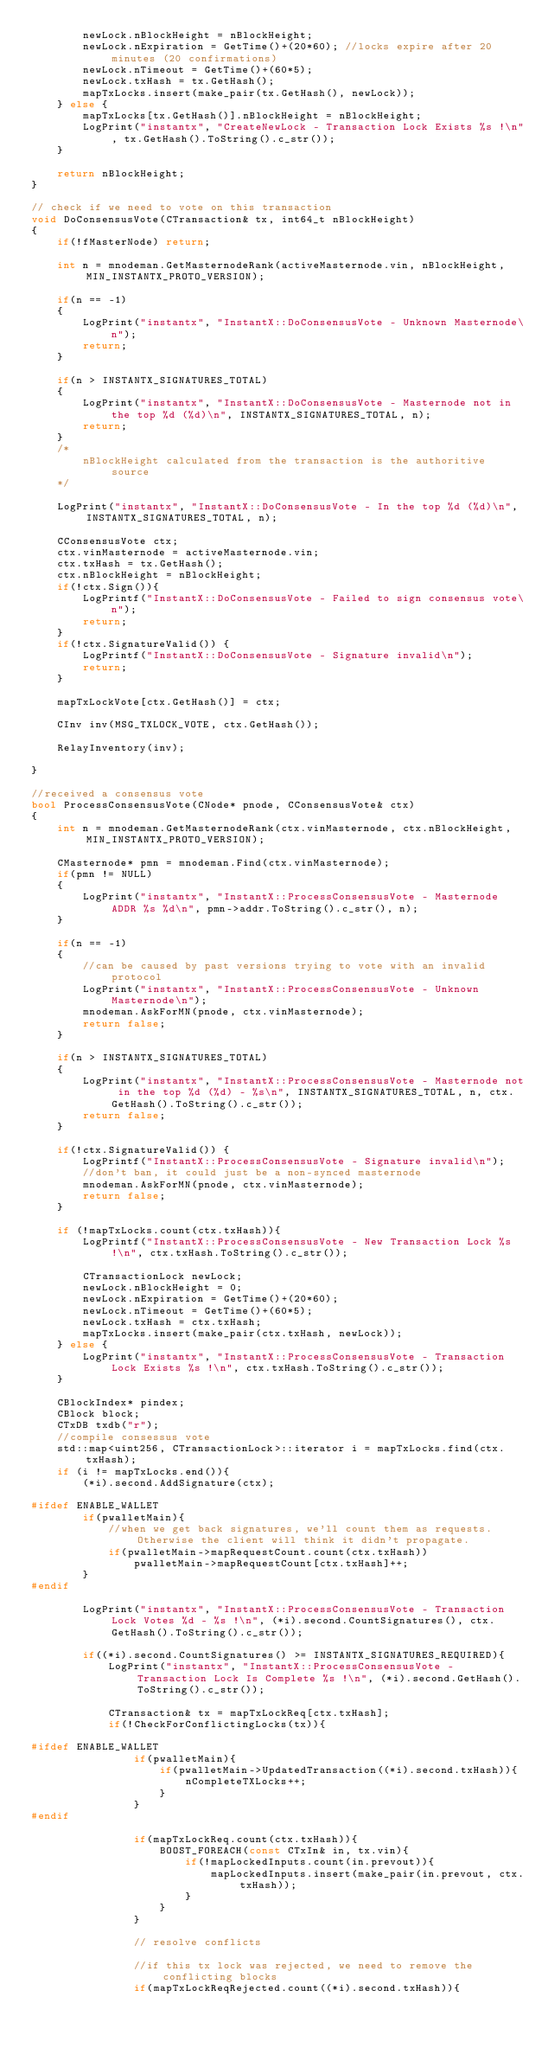<code> <loc_0><loc_0><loc_500><loc_500><_C++_>        newLock.nBlockHeight = nBlockHeight;
        newLock.nExpiration = GetTime()+(20*60); //locks expire after 20 minutes (20 confirmations)
        newLock.nTimeout = GetTime()+(60*5);
        newLock.txHash = tx.GetHash();
        mapTxLocks.insert(make_pair(tx.GetHash(), newLock));
    } else {
        mapTxLocks[tx.GetHash()].nBlockHeight = nBlockHeight;
        LogPrint("instantx", "CreateNewLock - Transaction Lock Exists %s !\n", tx.GetHash().ToString().c_str());
    }

    return nBlockHeight;
}

// check if we need to vote on this transaction
void DoConsensusVote(CTransaction& tx, int64_t nBlockHeight)
{
    if(!fMasterNode) return;

    int n = mnodeman.GetMasternodeRank(activeMasternode.vin, nBlockHeight, MIN_INSTANTX_PROTO_VERSION);

    if(n == -1)
    {
        LogPrint("instantx", "InstantX::DoConsensusVote - Unknown Masternode\n");
        return;
    }

    if(n > INSTANTX_SIGNATURES_TOTAL)
    {
        LogPrint("instantx", "InstantX::DoConsensusVote - Masternode not in the top %d (%d)\n", INSTANTX_SIGNATURES_TOTAL, n);
        return;
    }
    /*
        nBlockHeight calculated from the transaction is the authoritive source
    */

    LogPrint("instantx", "InstantX::DoConsensusVote - In the top %d (%d)\n", INSTANTX_SIGNATURES_TOTAL, n);

    CConsensusVote ctx;
    ctx.vinMasternode = activeMasternode.vin;
    ctx.txHash = tx.GetHash();
    ctx.nBlockHeight = nBlockHeight;
    if(!ctx.Sign()){
        LogPrintf("InstantX::DoConsensusVote - Failed to sign consensus vote\n");
        return;
    }
    if(!ctx.SignatureValid()) {
        LogPrintf("InstantX::DoConsensusVote - Signature invalid\n");
        return;
    }

    mapTxLockVote[ctx.GetHash()] = ctx;

    CInv inv(MSG_TXLOCK_VOTE, ctx.GetHash());

    RelayInventory(inv);

}

//received a consensus vote
bool ProcessConsensusVote(CNode* pnode, CConsensusVote& ctx)
{
    int n = mnodeman.GetMasternodeRank(ctx.vinMasternode, ctx.nBlockHeight, MIN_INSTANTX_PROTO_VERSION);

    CMasternode* pmn = mnodeman.Find(ctx.vinMasternode);
    if(pmn != NULL)
    {
        LogPrint("instantx", "InstantX::ProcessConsensusVote - Masternode ADDR %s %d\n", pmn->addr.ToString().c_str(), n);
    }

    if(n == -1)
    {
        //can be caused by past versions trying to vote with an invalid protocol
        LogPrint("instantx", "InstantX::ProcessConsensusVote - Unknown Masternode\n");
        mnodeman.AskForMN(pnode, ctx.vinMasternode);
        return false;
    }

    if(n > INSTANTX_SIGNATURES_TOTAL)
    {
        LogPrint("instantx", "InstantX::ProcessConsensusVote - Masternode not in the top %d (%d) - %s\n", INSTANTX_SIGNATURES_TOTAL, n, ctx.GetHash().ToString().c_str());
        return false;
    }

    if(!ctx.SignatureValid()) {
        LogPrintf("InstantX::ProcessConsensusVote - Signature invalid\n");
        //don't ban, it could just be a non-synced masternode
        mnodeman.AskForMN(pnode, ctx.vinMasternode);
        return false;
    }

    if (!mapTxLocks.count(ctx.txHash)){
        LogPrintf("InstantX::ProcessConsensusVote - New Transaction Lock %s !\n", ctx.txHash.ToString().c_str());

        CTransactionLock newLock;
        newLock.nBlockHeight = 0;
        newLock.nExpiration = GetTime()+(20*60);
        newLock.nTimeout = GetTime()+(60*5);
        newLock.txHash = ctx.txHash;
        mapTxLocks.insert(make_pair(ctx.txHash, newLock));
    } else {
        LogPrint("instantx", "InstantX::ProcessConsensusVote - Transaction Lock Exists %s !\n", ctx.txHash.ToString().c_str());
    }

    CBlockIndex* pindex;
    CBlock block;
    CTxDB txdb("r");
    //compile consessus vote
    std::map<uint256, CTransactionLock>::iterator i = mapTxLocks.find(ctx.txHash);
    if (i != mapTxLocks.end()){
        (*i).second.AddSignature(ctx);

#ifdef ENABLE_WALLET
        if(pwalletMain){
            //when we get back signatures, we'll count them as requests. Otherwise the client will think it didn't propagate.
            if(pwalletMain->mapRequestCount.count(ctx.txHash))
                pwalletMain->mapRequestCount[ctx.txHash]++;
        }
#endif

        LogPrint("instantx", "InstantX::ProcessConsensusVote - Transaction Lock Votes %d - %s !\n", (*i).second.CountSignatures(), ctx.GetHash().ToString().c_str());

        if((*i).second.CountSignatures() >= INSTANTX_SIGNATURES_REQUIRED){
            LogPrint("instantx", "InstantX::ProcessConsensusVote - Transaction Lock Is Complete %s !\n", (*i).second.GetHash().ToString().c_str());

            CTransaction& tx = mapTxLockReq[ctx.txHash];
            if(!CheckForConflictingLocks(tx)){

#ifdef ENABLE_WALLET
                if(pwalletMain){
                    if(pwalletMain->UpdatedTransaction((*i).second.txHash)){
                        nCompleteTXLocks++;
                    }
                }
#endif

                if(mapTxLockReq.count(ctx.txHash)){
                    BOOST_FOREACH(const CTxIn& in, tx.vin){
                        if(!mapLockedInputs.count(in.prevout)){
                            mapLockedInputs.insert(make_pair(in.prevout, ctx.txHash));
                        }
                    }
                }

                // resolve conflicts

                //if this tx lock was rejected, we need to remove the conflicting blocks
                if(mapTxLockReqRejected.count((*i).second.txHash)){</code> 